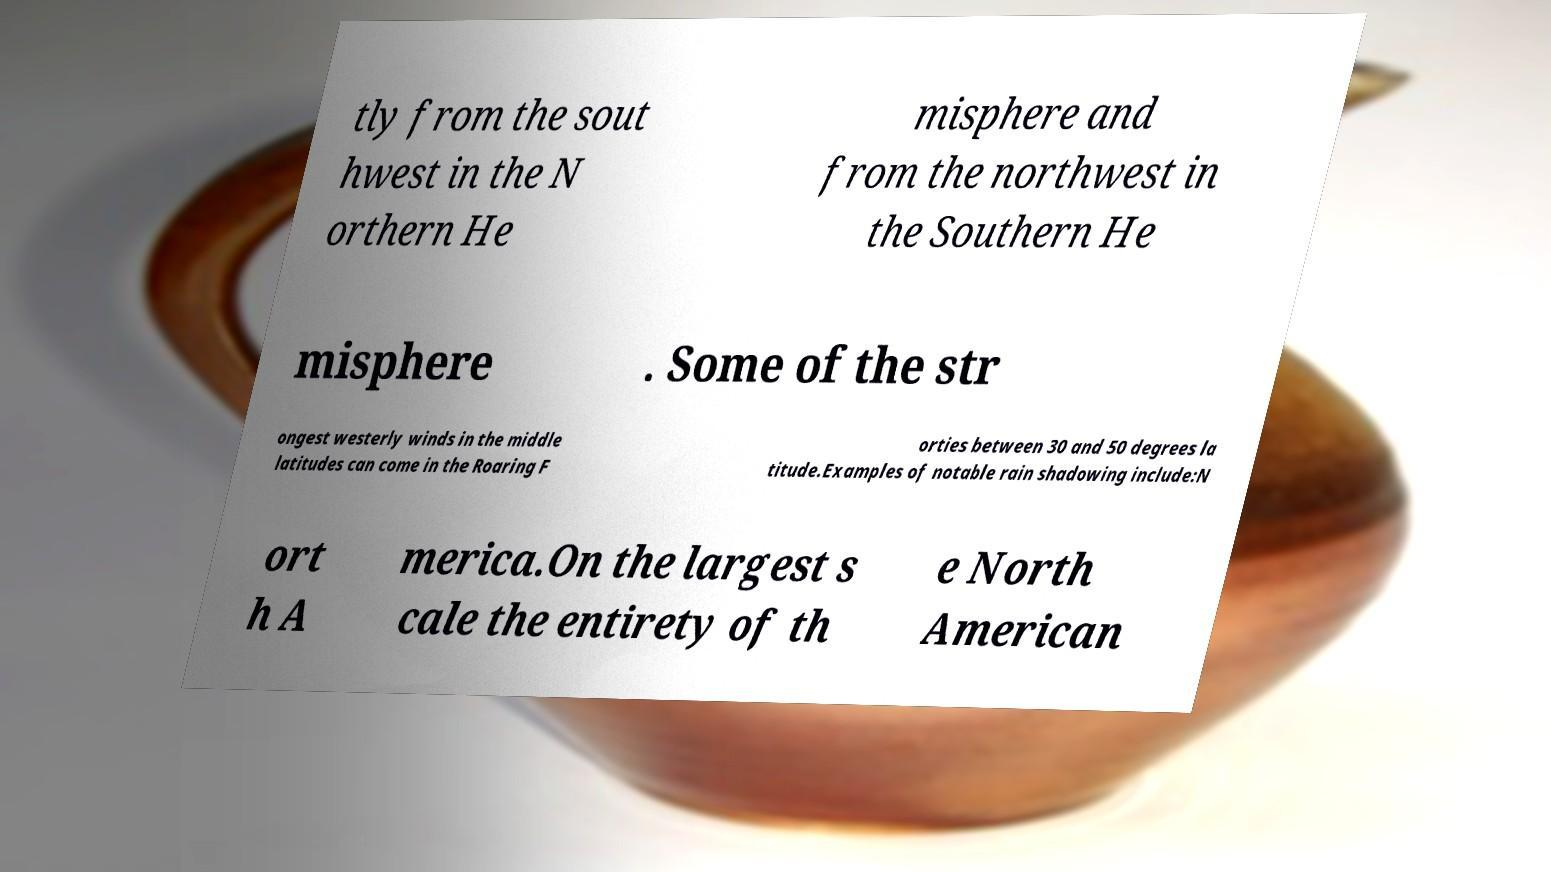Can you accurately transcribe the text from the provided image for me? tly from the sout hwest in the N orthern He misphere and from the northwest in the Southern He misphere . Some of the str ongest westerly winds in the middle latitudes can come in the Roaring F orties between 30 and 50 degrees la titude.Examples of notable rain shadowing include:N ort h A merica.On the largest s cale the entirety of th e North American 